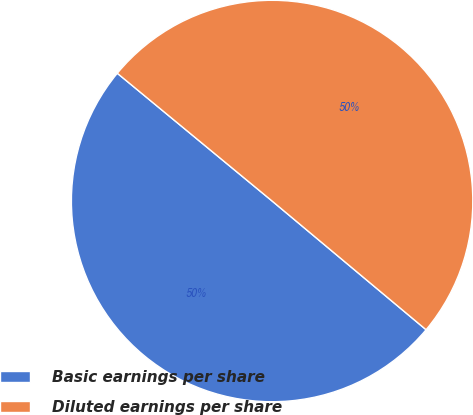Convert chart to OTSL. <chart><loc_0><loc_0><loc_500><loc_500><pie_chart><fcel>Basic earnings per share<fcel>Diluted earnings per share<nl><fcel>49.9%<fcel>50.1%<nl></chart> 